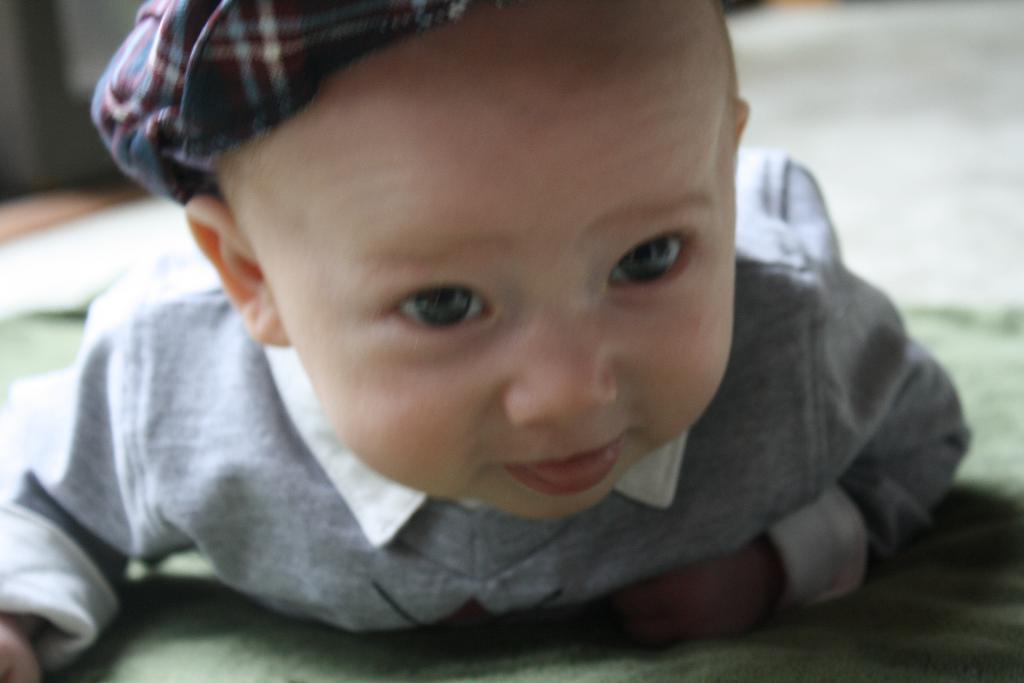Who is the main subject in the image? There is a little boy in the image. What is the boy doing in the image? The boy is laying on the surface of a carpet. What type of star can be seen in the image? There is no star visible in the image; it features a little boy laying on a carpet. 